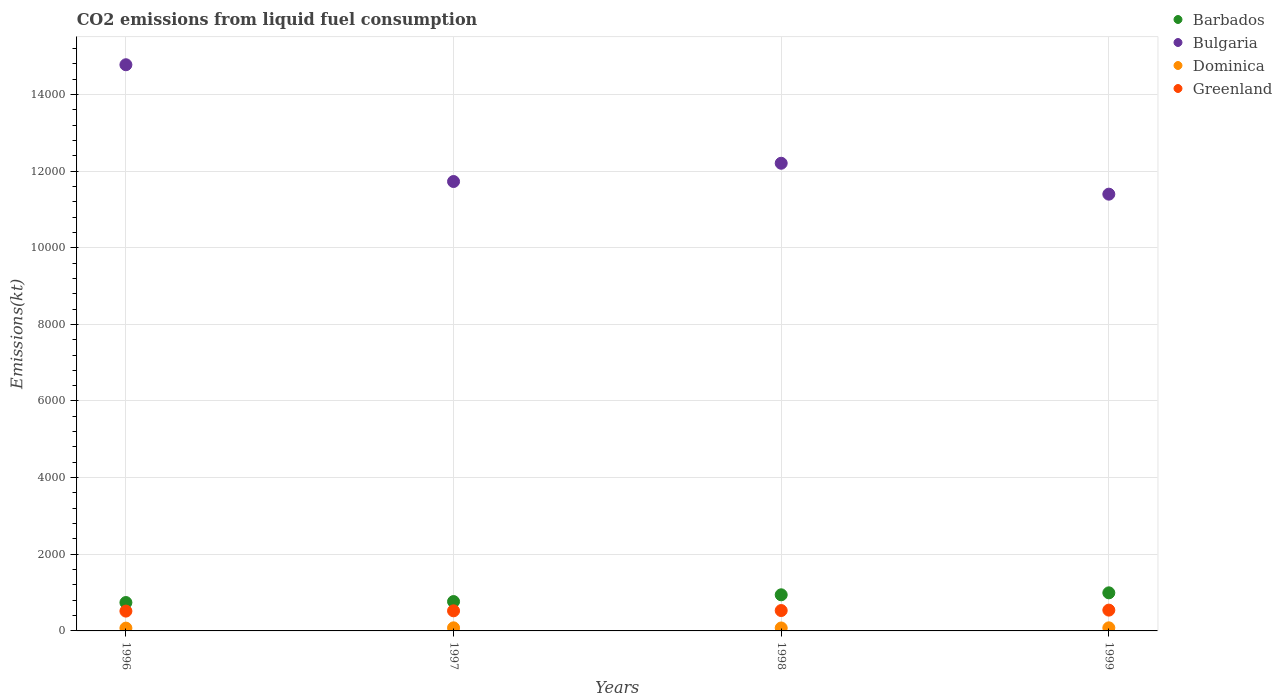How many different coloured dotlines are there?
Make the answer very short. 4. What is the amount of CO2 emitted in Bulgaria in 1999?
Provide a short and direct response. 1.14e+04. Across all years, what is the maximum amount of CO2 emitted in Greenland?
Offer a very short reply. 542.72. Across all years, what is the minimum amount of CO2 emitted in Bulgaria?
Keep it short and to the point. 1.14e+04. What is the total amount of CO2 emitted in Dominica in the graph?
Your response must be concise. 311.69. What is the difference between the amount of CO2 emitted in Greenland in 1996 and that in 1999?
Offer a very short reply. -25.67. What is the difference between the amount of CO2 emitted in Greenland in 1997 and the amount of CO2 emitted in Bulgaria in 1999?
Offer a terse response. -1.09e+04. What is the average amount of CO2 emitted in Dominica per year?
Your response must be concise. 77.92. In the year 1998, what is the difference between the amount of CO2 emitted in Dominica and amount of CO2 emitted in Greenland?
Offer a terse response. -454.71. In how many years, is the amount of CO2 emitted in Dominica greater than 1200 kt?
Give a very brief answer. 0. What is the ratio of the amount of CO2 emitted in Barbados in 1996 to that in 1999?
Your response must be concise. 0.75. Is the difference between the amount of CO2 emitted in Dominica in 1996 and 1997 greater than the difference between the amount of CO2 emitted in Greenland in 1996 and 1997?
Provide a succinct answer. No. What is the difference between the highest and the second highest amount of CO2 emitted in Greenland?
Your response must be concise. 11. What is the difference between the highest and the lowest amount of CO2 emitted in Greenland?
Your answer should be very brief. 25.67. Is the sum of the amount of CO2 emitted in Greenland in 1998 and 1999 greater than the maximum amount of CO2 emitted in Dominica across all years?
Keep it short and to the point. Yes. Is it the case that in every year, the sum of the amount of CO2 emitted in Barbados and amount of CO2 emitted in Greenland  is greater than the amount of CO2 emitted in Bulgaria?
Offer a very short reply. No. How many dotlines are there?
Give a very brief answer. 4. How many years are there in the graph?
Provide a succinct answer. 4. Does the graph contain grids?
Keep it short and to the point. Yes. Where does the legend appear in the graph?
Keep it short and to the point. Top right. How are the legend labels stacked?
Ensure brevity in your answer.  Vertical. What is the title of the graph?
Provide a short and direct response. CO2 emissions from liquid fuel consumption. What is the label or title of the Y-axis?
Your answer should be very brief. Emissions(kt). What is the Emissions(kt) of Barbados in 1996?
Offer a very short reply. 740.73. What is the Emissions(kt) of Bulgaria in 1996?
Offer a terse response. 1.48e+04. What is the Emissions(kt) in Dominica in 1996?
Offer a very short reply. 73.34. What is the Emissions(kt) of Greenland in 1996?
Offer a very short reply. 517.05. What is the Emissions(kt) of Barbados in 1997?
Your answer should be very brief. 766.4. What is the Emissions(kt) in Bulgaria in 1997?
Your response must be concise. 1.17e+04. What is the Emissions(kt) of Dominica in 1997?
Offer a terse response. 80.67. What is the Emissions(kt) in Greenland in 1997?
Your response must be concise. 524.38. What is the Emissions(kt) in Barbados in 1998?
Your response must be concise. 942.42. What is the Emissions(kt) in Bulgaria in 1998?
Provide a succinct answer. 1.22e+04. What is the Emissions(kt) in Dominica in 1998?
Give a very brief answer. 77.01. What is the Emissions(kt) in Greenland in 1998?
Your answer should be compact. 531.72. What is the Emissions(kt) in Barbados in 1999?
Your answer should be very brief. 993.76. What is the Emissions(kt) in Bulgaria in 1999?
Your response must be concise. 1.14e+04. What is the Emissions(kt) in Dominica in 1999?
Your answer should be compact. 80.67. What is the Emissions(kt) in Greenland in 1999?
Ensure brevity in your answer.  542.72. Across all years, what is the maximum Emissions(kt) in Barbados?
Make the answer very short. 993.76. Across all years, what is the maximum Emissions(kt) of Bulgaria?
Keep it short and to the point. 1.48e+04. Across all years, what is the maximum Emissions(kt) in Dominica?
Provide a short and direct response. 80.67. Across all years, what is the maximum Emissions(kt) in Greenland?
Your answer should be compact. 542.72. Across all years, what is the minimum Emissions(kt) of Barbados?
Ensure brevity in your answer.  740.73. Across all years, what is the minimum Emissions(kt) of Bulgaria?
Your answer should be compact. 1.14e+04. Across all years, what is the minimum Emissions(kt) in Dominica?
Your answer should be very brief. 73.34. Across all years, what is the minimum Emissions(kt) in Greenland?
Provide a succinct answer. 517.05. What is the total Emissions(kt) in Barbados in the graph?
Offer a very short reply. 3443.31. What is the total Emissions(kt) in Bulgaria in the graph?
Provide a succinct answer. 5.01e+04. What is the total Emissions(kt) of Dominica in the graph?
Offer a terse response. 311.69. What is the total Emissions(kt) in Greenland in the graph?
Offer a very short reply. 2115.86. What is the difference between the Emissions(kt) of Barbados in 1996 and that in 1997?
Your answer should be very brief. -25.67. What is the difference between the Emissions(kt) of Bulgaria in 1996 and that in 1997?
Give a very brief answer. 3047.28. What is the difference between the Emissions(kt) in Dominica in 1996 and that in 1997?
Your response must be concise. -7.33. What is the difference between the Emissions(kt) in Greenland in 1996 and that in 1997?
Offer a very short reply. -7.33. What is the difference between the Emissions(kt) of Barbados in 1996 and that in 1998?
Provide a short and direct response. -201.69. What is the difference between the Emissions(kt) of Bulgaria in 1996 and that in 1998?
Ensure brevity in your answer.  2570.57. What is the difference between the Emissions(kt) of Dominica in 1996 and that in 1998?
Your answer should be compact. -3.67. What is the difference between the Emissions(kt) of Greenland in 1996 and that in 1998?
Ensure brevity in your answer.  -14.67. What is the difference between the Emissions(kt) in Barbados in 1996 and that in 1999?
Give a very brief answer. -253.02. What is the difference between the Emissions(kt) in Bulgaria in 1996 and that in 1999?
Your answer should be very brief. 3377.31. What is the difference between the Emissions(kt) of Dominica in 1996 and that in 1999?
Your answer should be compact. -7.33. What is the difference between the Emissions(kt) in Greenland in 1996 and that in 1999?
Ensure brevity in your answer.  -25.67. What is the difference between the Emissions(kt) in Barbados in 1997 and that in 1998?
Provide a succinct answer. -176.02. What is the difference between the Emissions(kt) in Bulgaria in 1997 and that in 1998?
Provide a succinct answer. -476.71. What is the difference between the Emissions(kt) in Dominica in 1997 and that in 1998?
Provide a short and direct response. 3.67. What is the difference between the Emissions(kt) in Greenland in 1997 and that in 1998?
Offer a very short reply. -7.33. What is the difference between the Emissions(kt) in Barbados in 1997 and that in 1999?
Make the answer very short. -227.35. What is the difference between the Emissions(kt) of Bulgaria in 1997 and that in 1999?
Your response must be concise. 330.03. What is the difference between the Emissions(kt) of Dominica in 1997 and that in 1999?
Provide a short and direct response. 0. What is the difference between the Emissions(kt) of Greenland in 1997 and that in 1999?
Offer a very short reply. -18.34. What is the difference between the Emissions(kt) in Barbados in 1998 and that in 1999?
Give a very brief answer. -51.34. What is the difference between the Emissions(kt) in Bulgaria in 1998 and that in 1999?
Give a very brief answer. 806.74. What is the difference between the Emissions(kt) of Dominica in 1998 and that in 1999?
Keep it short and to the point. -3.67. What is the difference between the Emissions(kt) in Greenland in 1998 and that in 1999?
Give a very brief answer. -11. What is the difference between the Emissions(kt) in Barbados in 1996 and the Emissions(kt) in Bulgaria in 1997?
Make the answer very short. -1.10e+04. What is the difference between the Emissions(kt) in Barbados in 1996 and the Emissions(kt) in Dominica in 1997?
Offer a very short reply. 660.06. What is the difference between the Emissions(kt) in Barbados in 1996 and the Emissions(kt) in Greenland in 1997?
Your answer should be very brief. 216.35. What is the difference between the Emissions(kt) in Bulgaria in 1996 and the Emissions(kt) in Dominica in 1997?
Make the answer very short. 1.47e+04. What is the difference between the Emissions(kt) in Bulgaria in 1996 and the Emissions(kt) in Greenland in 1997?
Provide a succinct answer. 1.42e+04. What is the difference between the Emissions(kt) of Dominica in 1996 and the Emissions(kt) of Greenland in 1997?
Your response must be concise. -451.04. What is the difference between the Emissions(kt) of Barbados in 1996 and the Emissions(kt) of Bulgaria in 1998?
Offer a terse response. -1.15e+04. What is the difference between the Emissions(kt) in Barbados in 1996 and the Emissions(kt) in Dominica in 1998?
Keep it short and to the point. 663.73. What is the difference between the Emissions(kt) of Barbados in 1996 and the Emissions(kt) of Greenland in 1998?
Your answer should be compact. 209.02. What is the difference between the Emissions(kt) in Bulgaria in 1996 and the Emissions(kt) in Dominica in 1998?
Make the answer very short. 1.47e+04. What is the difference between the Emissions(kt) in Bulgaria in 1996 and the Emissions(kt) in Greenland in 1998?
Provide a succinct answer. 1.42e+04. What is the difference between the Emissions(kt) of Dominica in 1996 and the Emissions(kt) of Greenland in 1998?
Make the answer very short. -458.38. What is the difference between the Emissions(kt) in Barbados in 1996 and the Emissions(kt) in Bulgaria in 1999?
Your answer should be very brief. -1.07e+04. What is the difference between the Emissions(kt) in Barbados in 1996 and the Emissions(kt) in Dominica in 1999?
Offer a very short reply. 660.06. What is the difference between the Emissions(kt) in Barbados in 1996 and the Emissions(kt) in Greenland in 1999?
Your response must be concise. 198.02. What is the difference between the Emissions(kt) in Bulgaria in 1996 and the Emissions(kt) in Dominica in 1999?
Make the answer very short. 1.47e+04. What is the difference between the Emissions(kt) of Bulgaria in 1996 and the Emissions(kt) of Greenland in 1999?
Offer a very short reply. 1.42e+04. What is the difference between the Emissions(kt) in Dominica in 1996 and the Emissions(kt) in Greenland in 1999?
Ensure brevity in your answer.  -469.38. What is the difference between the Emissions(kt) of Barbados in 1997 and the Emissions(kt) of Bulgaria in 1998?
Your answer should be very brief. -1.14e+04. What is the difference between the Emissions(kt) of Barbados in 1997 and the Emissions(kt) of Dominica in 1998?
Ensure brevity in your answer.  689.4. What is the difference between the Emissions(kt) in Barbados in 1997 and the Emissions(kt) in Greenland in 1998?
Your answer should be very brief. 234.69. What is the difference between the Emissions(kt) of Bulgaria in 1997 and the Emissions(kt) of Dominica in 1998?
Offer a very short reply. 1.17e+04. What is the difference between the Emissions(kt) in Bulgaria in 1997 and the Emissions(kt) in Greenland in 1998?
Ensure brevity in your answer.  1.12e+04. What is the difference between the Emissions(kt) of Dominica in 1997 and the Emissions(kt) of Greenland in 1998?
Offer a very short reply. -451.04. What is the difference between the Emissions(kt) of Barbados in 1997 and the Emissions(kt) of Bulgaria in 1999?
Make the answer very short. -1.06e+04. What is the difference between the Emissions(kt) of Barbados in 1997 and the Emissions(kt) of Dominica in 1999?
Ensure brevity in your answer.  685.73. What is the difference between the Emissions(kt) of Barbados in 1997 and the Emissions(kt) of Greenland in 1999?
Offer a very short reply. 223.69. What is the difference between the Emissions(kt) in Bulgaria in 1997 and the Emissions(kt) in Dominica in 1999?
Provide a short and direct response. 1.16e+04. What is the difference between the Emissions(kt) in Bulgaria in 1997 and the Emissions(kt) in Greenland in 1999?
Your answer should be very brief. 1.12e+04. What is the difference between the Emissions(kt) in Dominica in 1997 and the Emissions(kt) in Greenland in 1999?
Offer a terse response. -462.04. What is the difference between the Emissions(kt) in Barbados in 1998 and the Emissions(kt) in Bulgaria in 1999?
Provide a succinct answer. -1.05e+04. What is the difference between the Emissions(kt) of Barbados in 1998 and the Emissions(kt) of Dominica in 1999?
Offer a very short reply. 861.75. What is the difference between the Emissions(kt) of Barbados in 1998 and the Emissions(kt) of Greenland in 1999?
Keep it short and to the point. 399.7. What is the difference between the Emissions(kt) of Bulgaria in 1998 and the Emissions(kt) of Dominica in 1999?
Offer a very short reply. 1.21e+04. What is the difference between the Emissions(kt) in Bulgaria in 1998 and the Emissions(kt) in Greenland in 1999?
Ensure brevity in your answer.  1.17e+04. What is the difference between the Emissions(kt) of Dominica in 1998 and the Emissions(kt) of Greenland in 1999?
Keep it short and to the point. -465.71. What is the average Emissions(kt) in Barbados per year?
Offer a very short reply. 860.83. What is the average Emissions(kt) in Bulgaria per year?
Give a very brief answer. 1.25e+04. What is the average Emissions(kt) of Dominica per year?
Keep it short and to the point. 77.92. What is the average Emissions(kt) of Greenland per year?
Your response must be concise. 528.96. In the year 1996, what is the difference between the Emissions(kt) in Barbados and Emissions(kt) in Bulgaria?
Provide a short and direct response. -1.40e+04. In the year 1996, what is the difference between the Emissions(kt) of Barbados and Emissions(kt) of Dominica?
Provide a short and direct response. 667.39. In the year 1996, what is the difference between the Emissions(kt) in Barbados and Emissions(kt) in Greenland?
Give a very brief answer. 223.69. In the year 1996, what is the difference between the Emissions(kt) in Bulgaria and Emissions(kt) in Dominica?
Your response must be concise. 1.47e+04. In the year 1996, what is the difference between the Emissions(kt) in Bulgaria and Emissions(kt) in Greenland?
Make the answer very short. 1.43e+04. In the year 1996, what is the difference between the Emissions(kt) in Dominica and Emissions(kt) in Greenland?
Your answer should be compact. -443.71. In the year 1997, what is the difference between the Emissions(kt) in Barbados and Emissions(kt) in Bulgaria?
Make the answer very short. -1.10e+04. In the year 1997, what is the difference between the Emissions(kt) in Barbados and Emissions(kt) in Dominica?
Your answer should be very brief. 685.73. In the year 1997, what is the difference between the Emissions(kt) of Barbados and Emissions(kt) of Greenland?
Keep it short and to the point. 242.02. In the year 1997, what is the difference between the Emissions(kt) in Bulgaria and Emissions(kt) in Dominica?
Your response must be concise. 1.16e+04. In the year 1997, what is the difference between the Emissions(kt) of Bulgaria and Emissions(kt) of Greenland?
Keep it short and to the point. 1.12e+04. In the year 1997, what is the difference between the Emissions(kt) of Dominica and Emissions(kt) of Greenland?
Provide a succinct answer. -443.71. In the year 1998, what is the difference between the Emissions(kt) of Barbados and Emissions(kt) of Bulgaria?
Give a very brief answer. -1.13e+04. In the year 1998, what is the difference between the Emissions(kt) of Barbados and Emissions(kt) of Dominica?
Your answer should be very brief. 865.41. In the year 1998, what is the difference between the Emissions(kt) in Barbados and Emissions(kt) in Greenland?
Keep it short and to the point. 410.7. In the year 1998, what is the difference between the Emissions(kt) of Bulgaria and Emissions(kt) of Dominica?
Your response must be concise. 1.21e+04. In the year 1998, what is the difference between the Emissions(kt) in Bulgaria and Emissions(kt) in Greenland?
Make the answer very short. 1.17e+04. In the year 1998, what is the difference between the Emissions(kt) in Dominica and Emissions(kt) in Greenland?
Your answer should be compact. -454.71. In the year 1999, what is the difference between the Emissions(kt) of Barbados and Emissions(kt) of Bulgaria?
Your answer should be compact. -1.04e+04. In the year 1999, what is the difference between the Emissions(kt) in Barbados and Emissions(kt) in Dominica?
Your answer should be compact. 913.08. In the year 1999, what is the difference between the Emissions(kt) of Barbados and Emissions(kt) of Greenland?
Your response must be concise. 451.04. In the year 1999, what is the difference between the Emissions(kt) in Bulgaria and Emissions(kt) in Dominica?
Your response must be concise. 1.13e+04. In the year 1999, what is the difference between the Emissions(kt) of Bulgaria and Emissions(kt) of Greenland?
Your answer should be compact. 1.09e+04. In the year 1999, what is the difference between the Emissions(kt) in Dominica and Emissions(kt) in Greenland?
Your response must be concise. -462.04. What is the ratio of the Emissions(kt) in Barbados in 1996 to that in 1997?
Keep it short and to the point. 0.97. What is the ratio of the Emissions(kt) in Bulgaria in 1996 to that in 1997?
Your answer should be compact. 1.26. What is the ratio of the Emissions(kt) of Dominica in 1996 to that in 1997?
Give a very brief answer. 0.91. What is the ratio of the Emissions(kt) of Greenland in 1996 to that in 1997?
Your answer should be compact. 0.99. What is the ratio of the Emissions(kt) in Barbados in 1996 to that in 1998?
Ensure brevity in your answer.  0.79. What is the ratio of the Emissions(kt) in Bulgaria in 1996 to that in 1998?
Your answer should be very brief. 1.21. What is the ratio of the Emissions(kt) of Greenland in 1996 to that in 1998?
Offer a terse response. 0.97. What is the ratio of the Emissions(kt) in Barbados in 1996 to that in 1999?
Ensure brevity in your answer.  0.75. What is the ratio of the Emissions(kt) in Bulgaria in 1996 to that in 1999?
Give a very brief answer. 1.3. What is the ratio of the Emissions(kt) of Dominica in 1996 to that in 1999?
Offer a terse response. 0.91. What is the ratio of the Emissions(kt) in Greenland in 1996 to that in 1999?
Ensure brevity in your answer.  0.95. What is the ratio of the Emissions(kt) of Barbados in 1997 to that in 1998?
Give a very brief answer. 0.81. What is the ratio of the Emissions(kt) of Bulgaria in 1997 to that in 1998?
Offer a terse response. 0.96. What is the ratio of the Emissions(kt) of Dominica in 1997 to that in 1998?
Keep it short and to the point. 1.05. What is the ratio of the Emissions(kt) in Greenland in 1997 to that in 1998?
Keep it short and to the point. 0.99. What is the ratio of the Emissions(kt) in Barbados in 1997 to that in 1999?
Your response must be concise. 0.77. What is the ratio of the Emissions(kt) of Bulgaria in 1997 to that in 1999?
Your answer should be compact. 1.03. What is the ratio of the Emissions(kt) of Dominica in 1997 to that in 1999?
Offer a terse response. 1. What is the ratio of the Emissions(kt) of Greenland in 1997 to that in 1999?
Offer a very short reply. 0.97. What is the ratio of the Emissions(kt) of Barbados in 1998 to that in 1999?
Provide a succinct answer. 0.95. What is the ratio of the Emissions(kt) of Bulgaria in 1998 to that in 1999?
Keep it short and to the point. 1.07. What is the ratio of the Emissions(kt) in Dominica in 1998 to that in 1999?
Your response must be concise. 0.95. What is the ratio of the Emissions(kt) of Greenland in 1998 to that in 1999?
Give a very brief answer. 0.98. What is the difference between the highest and the second highest Emissions(kt) in Barbados?
Provide a succinct answer. 51.34. What is the difference between the highest and the second highest Emissions(kt) of Bulgaria?
Provide a short and direct response. 2570.57. What is the difference between the highest and the second highest Emissions(kt) of Dominica?
Ensure brevity in your answer.  0. What is the difference between the highest and the second highest Emissions(kt) of Greenland?
Make the answer very short. 11. What is the difference between the highest and the lowest Emissions(kt) of Barbados?
Provide a succinct answer. 253.02. What is the difference between the highest and the lowest Emissions(kt) in Bulgaria?
Provide a succinct answer. 3377.31. What is the difference between the highest and the lowest Emissions(kt) in Dominica?
Your answer should be very brief. 7.33. What is the difference between the highest and the lowest Emissions(kt) in Greenland?
Give a very brief answer. 25.67. 